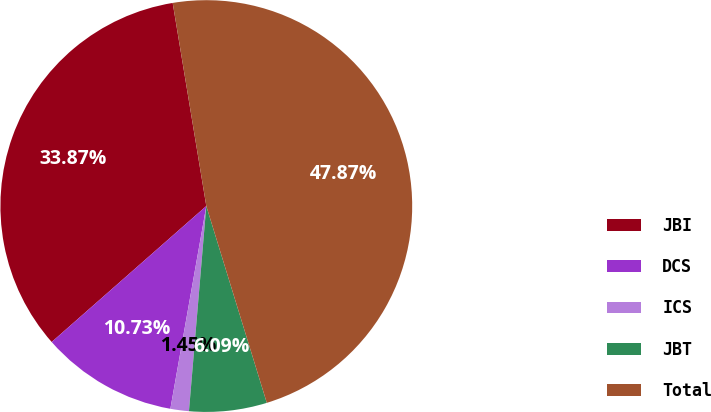Convert chart to OTSL. <chart><loc_0><loc_0><loc_500><loc_500><pie_chart><fcel>JBI<fcel>DCS<fcel>ICS<fcel>JBT<fcel>Total<nl><fcel>33.87%<fcel>10.73%<fcel>1.45%<fcel>6.09%<fcel>47.87%<nl></chart> 